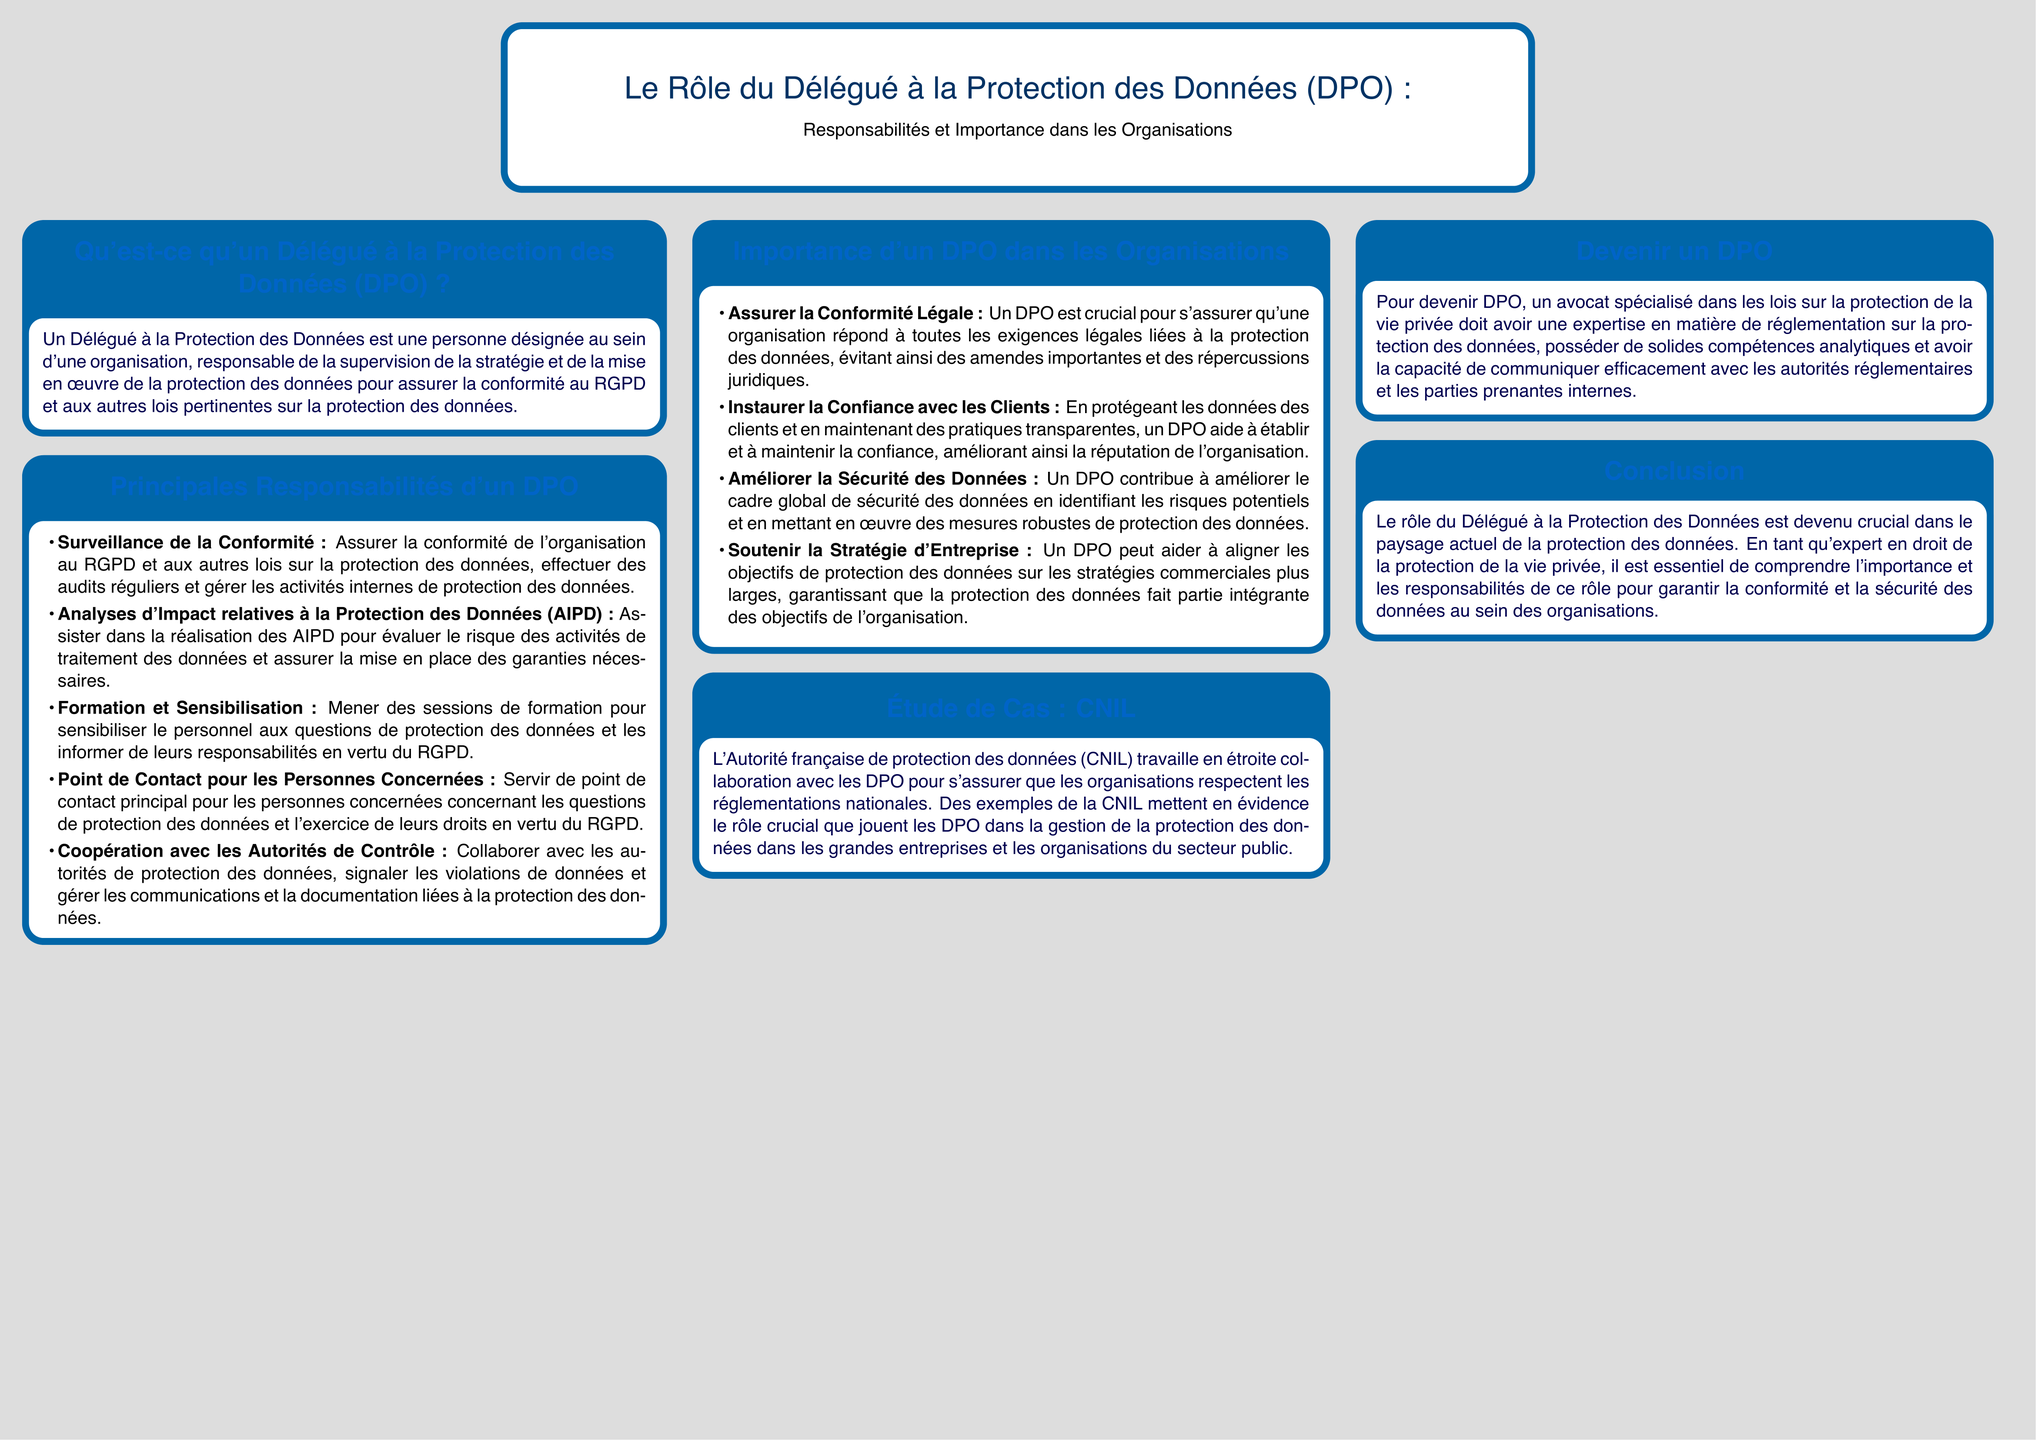Qu'est-ce qu'un Délégué à la Protection des Données (DPO) ? Un DPO est défini dans le document comme une personne désignée au sein d'une organisation, responsable de la supervision de la stratégie et de la mise en œuvre de la protection des données.
Answer: Une personne désignée Quelles sont les principales responsabilités d'un DPO ? Le document énumère plusieurs responsabilités principales que doit assumer un DPO, qui incluent la surveillance de la conformité et l’assistance dans la réalisation des AIPD.
Answer: Surveillance de la conformité Pourquoi est-il important d'avoir un DPO dans une organisation ? Le rôle d'un DPO est crucial pour plusieurs raisons, notamment pour assurer la conformité légale et instaurer la confiance avec les clients.
Answer: Assurer la conformité légale Quel est le rôle de la CNIL par rapport aux DPO ? Le document mentionne que la CNIL collabore avec les DPO pour assurer le respect des réglementations nationales.
Answer: Collaborer avec les DPO Que doit posséder une personne pour devenir un DPO ? Pour devenir DPO, il est indiqué que posséder une expertise en réglementation sur la protection des données est nécessaire.
Answer: Expertise en réglementation Quelle est la relation entre les objectifs de protection des données et la stratégie d'entreprise, selon le DPO ? Le DPO aide à aligner les objectifs de protection des données sur les stratégies commerciales plus larges, garantissant leur intégration.
Answer: Aligner les objectifs Quelle analyse doit réaliser un DPO pour évaluer le risque des activités de traitement des données ? Le document indique que le DPO doit assister dans la réalisation des Analyses d'Impact relatives à la Protection des Données (AIPD).
Answer: AIPD Combien de colonnes sont présentées dans le poster ? En analysant la structure du document, il est mentionné qu'il y a trois colonnes.
Answer: Trois colonnes 